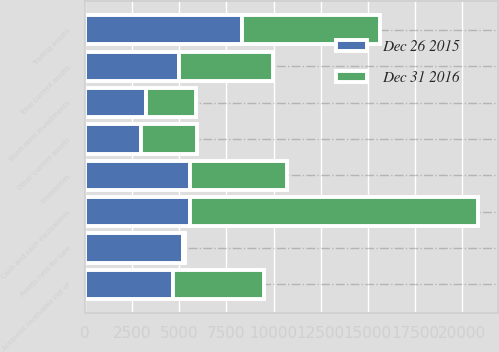<chart> <loc_0><loc_0><loc_500><loc_500><stacked_bar_chart><ecel><fcel>Cash and cash equivalents<fcel>Short-term investments<fcel>Trading assets<fcel>Accounts receivable net of<fcel>Inventories<fcel>Assets held for sale<fcel>Other current assets<fcel>Total current assets<nl><fcel>Dec 26 2015<fcel>5560<fcel>3225<fcel>8314<fcel>4690<fcel>5553<fcel>5210<fcel>2956<fcel>4977<nl><fcel>Dec 31 2016<fcel>15308<fcel>2682<fcel>7323<fcel>4787<fcel>5167<fcel>71<fcel>2982<fcel>4977<nl></chart> 